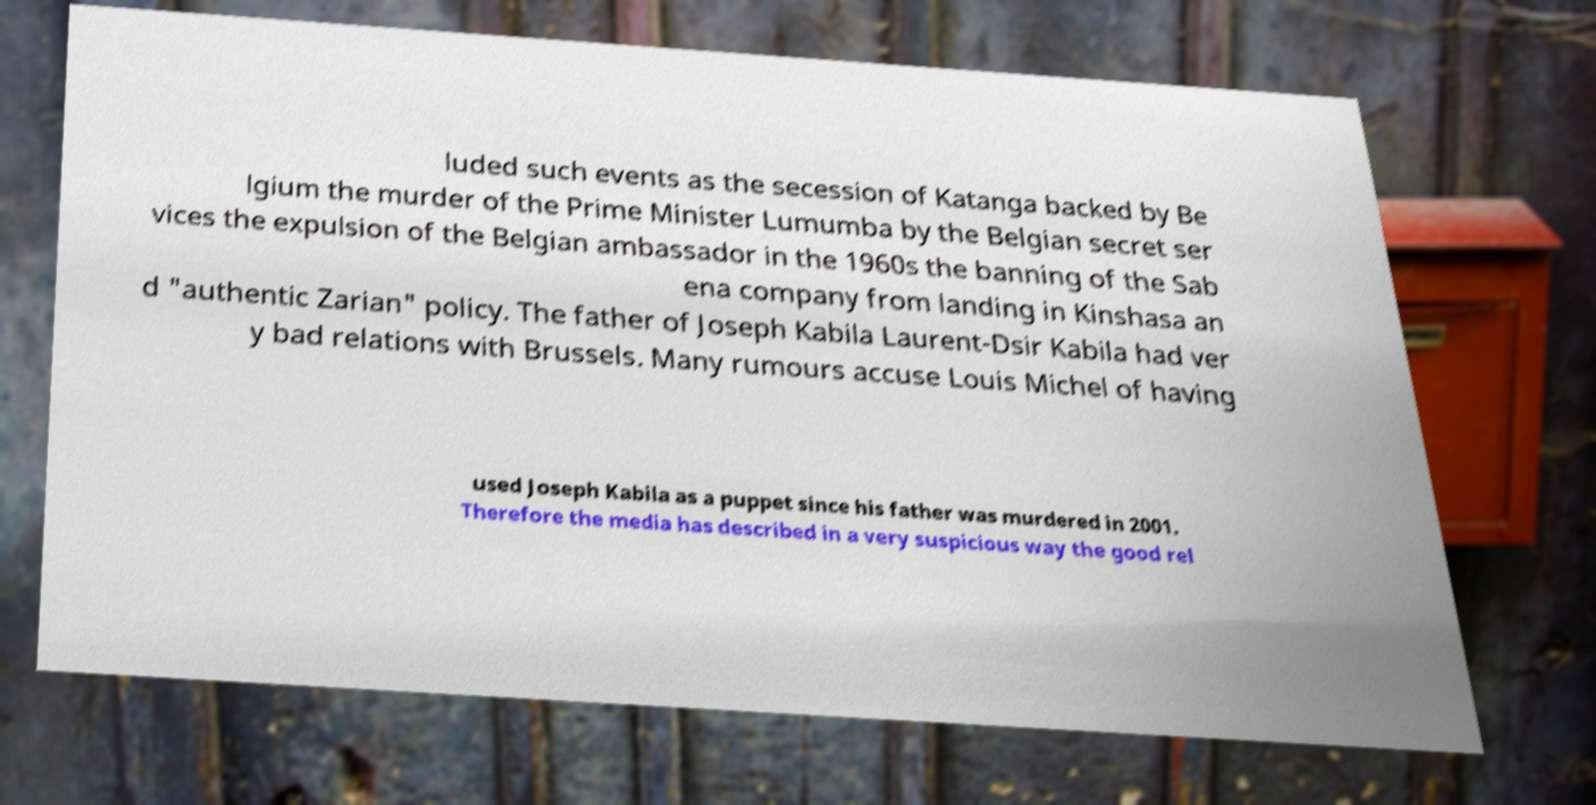Can you read and provide the text displayed in the image?This photo seems to have some interesting text. Can you extract and type it out for me? luded such events as the secession of Katanga backed by Be lgium the murder of the Prime Minister Lumumba by the Belgian secret ser vices the expulsion of the Belgian ambassador in the 1960s the banning of the Sab ena company from landing in Kinshasa an d "authentic Zarian" policy. The father of Joseph Kabila Laurent-Dsir Kabila had ver y bad relations with Brussels. Many rumours accuse Louis Michel of having used Joseph Kabila as a puppet since his father was murdered in 2001. Therefore the media has described in a very suspicious way the good rel 